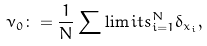<formula> <loc_0><loc_0><loc_500><loc_500>\nu _ { 0 } \colon = \frac { 1 } { N } \sum \lim i t s _ { i = 1 } ^ { N } \delta _ { x _ { i } } ,</formula> 